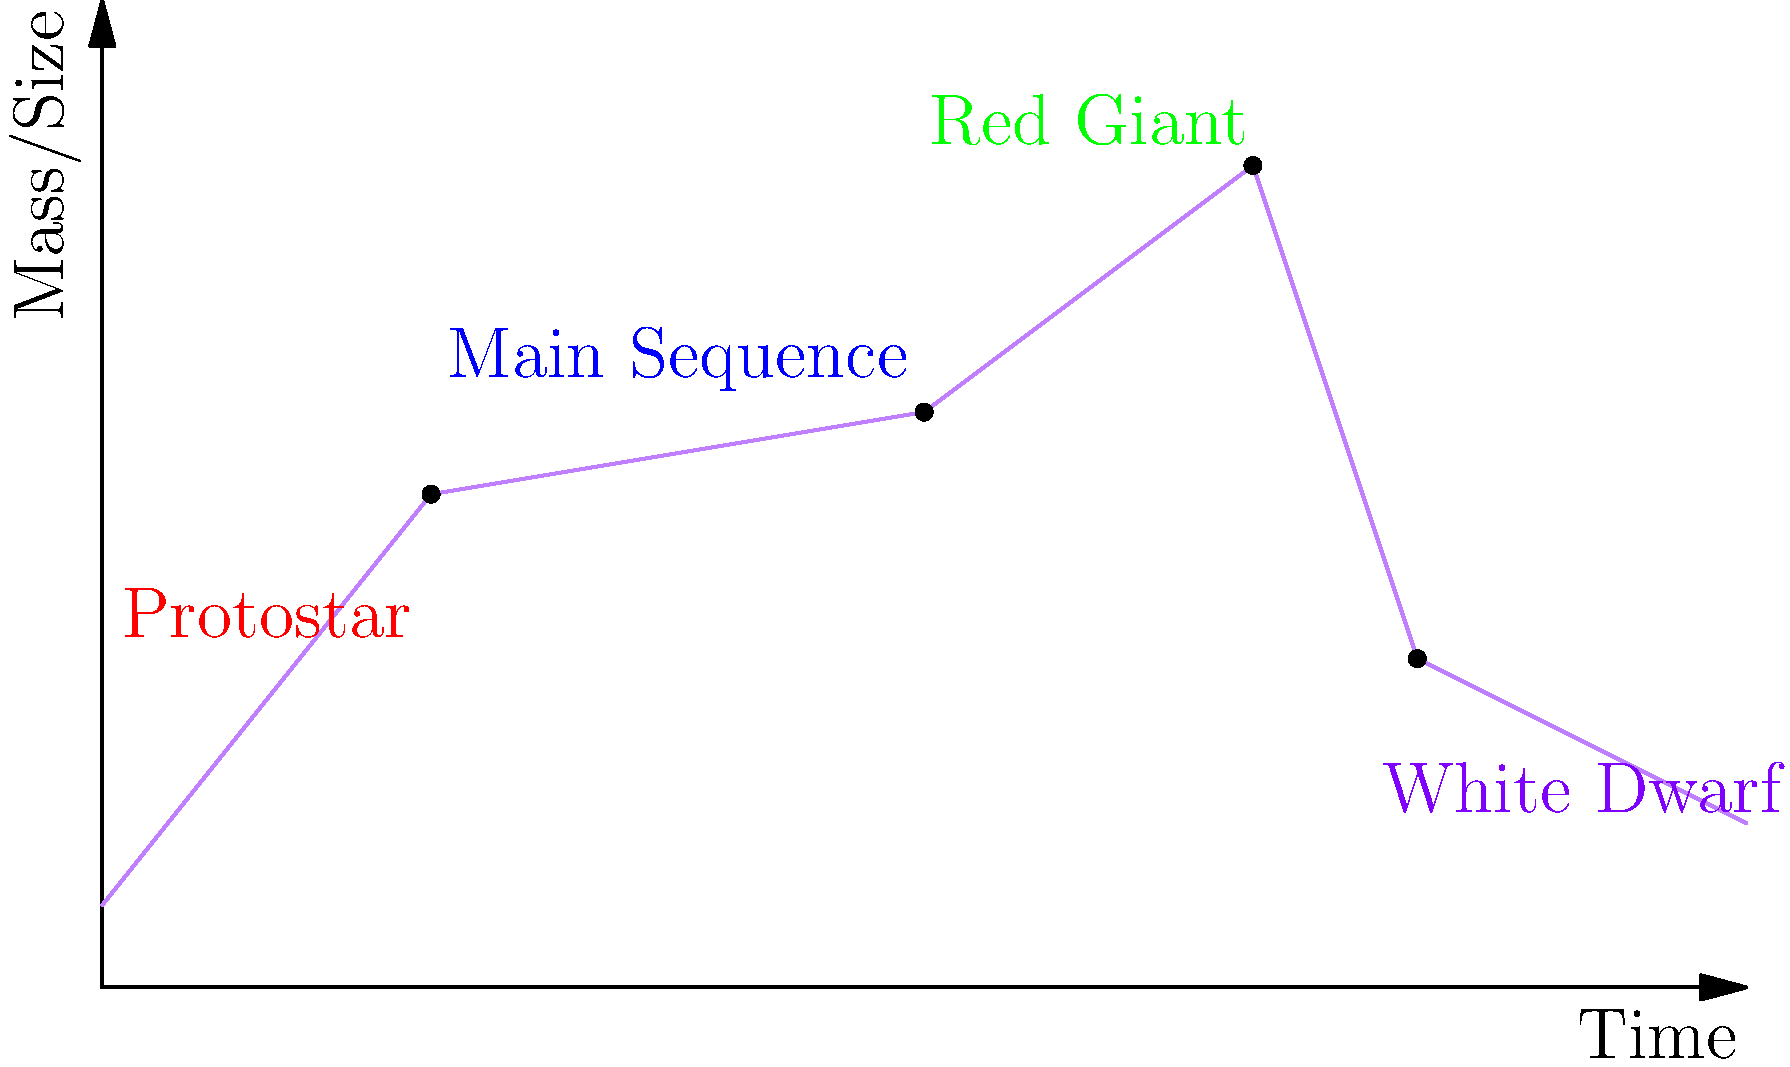In the context of a star's life cycle, which phase is characterized by a significant increase in size but a decrease in surface temperature, often appearing reddish in color? How does this phase relate to the star's fusion processes and its ultimate fate? To answer this question, let's break down the life cycle of a star:

1. Protostar formation: A cloud of gas and dust collapses under gravity.

2. Main Sequence: The star stabilizes, fusing hydrogen into helium in its core. This is the longest phase of a star's life.

3. Red Giant phase:
   a) The star exhausts its core hydrogen fuel.
   b) The core contracts and heats up, initiating hydrogen fusion in a shell around the core.
   c) The outer layers expand dramatically, increasing the star's size.
   d) As the surface area increases, the surface temperature decreases, making the star appear reddish.
   e) The star's luminosity increases despite the lower surface temperature due to its larger size.

4. End states (depending on the star's initial mass):
   a) For low to medium-mass stars (like our Sun):
      - The core eventually becomes hot enough to fuse helium into carbon and oxygen.
      - The star's outer layers are eventually expelled, forming a planetary nebula.
      - The core becomes a white dwarf.
   b) For high-mass stars:
      - They can progress to fusing heavier elements.
      - They may end as neutron stars or black holes after a supernova explosion.

The Red Giant phase is characterized by the significant increase in size and reddish appearance. It's a crucial stage that bridges the Main Sequence and the star's ultimate fate, whether as a white dwarf or a more exotic object for more massive stars.
Answer: Red Giant phase 